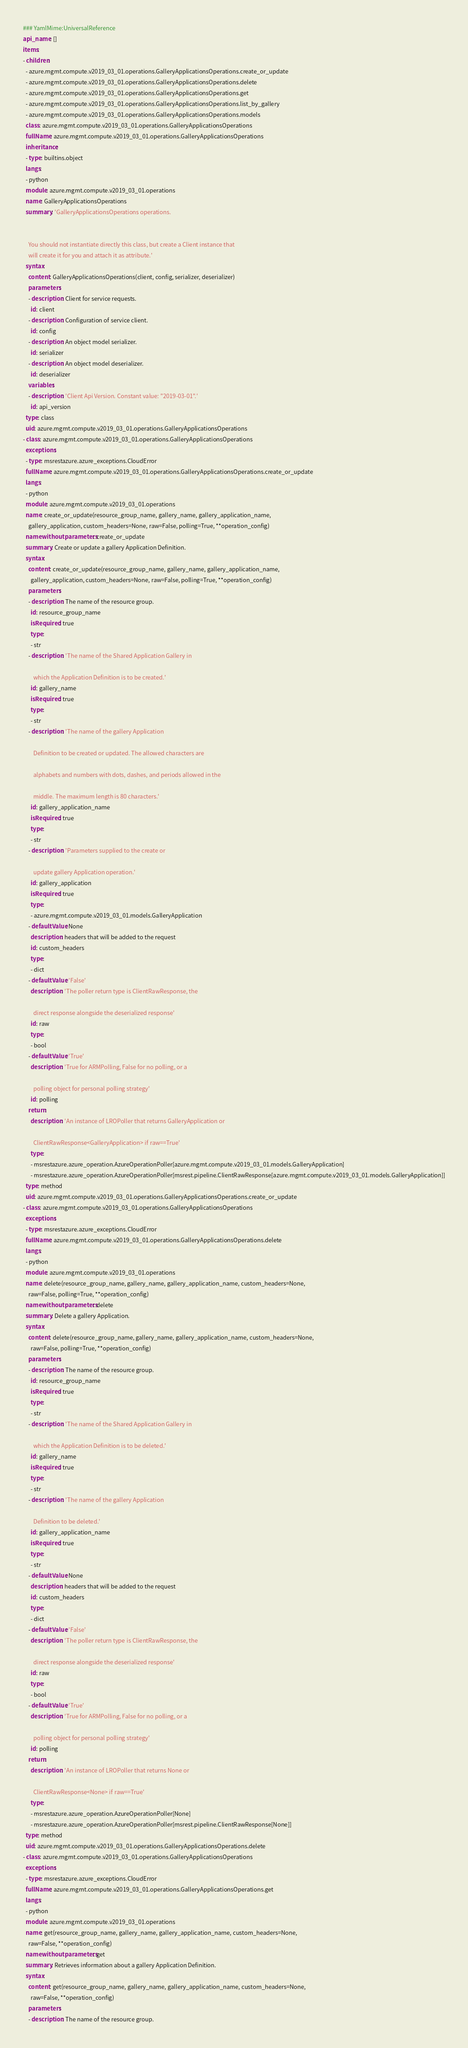<code> <loc_0><loc_0><loc_500><loc_500><_YAML_>### YamlMime:UniversalReference
api_name: []
items:
- children:
  - azure.mgmt.compute.v2019_03_01.operations.GalleryApplicationsOperations.create_or_update
  - azure.mgmt.compute.v2019_03_01.operations.GalleryApplicationsOperations.delete
  - azure.mgmt.compute.v2019_03_01.operations.GalleryApplicationsOperations.get
  - azure.mgmt.compute.v2019_03_01.operations.GalleryApplicationsOperations.list_by_gallery
  - azure.mgmt.compute.v2019_03_01.operations.GalleryApplicationsOperations.models
  class: azure.mgmt.compute.v2019_03_01.operations.GalleryApplicationsOperations
  fullName: azure.mgmt.compute.v2019_03_01.operations.GalleryApplicationsOperations
  inheritance:
  - type: builtins.object
  langs:
  - python
  module: azure.mgmt.compute.v2019_03_01.operations
  name: GalleryApplicationsOperations
  summary: 'GalleryApplicationsOperations operations.


    You should not instantiate directly this class, but create a Client instance that
    will create it for you and attach it as attribute.'
  syntax:
    content: GalleryApplicationsOperations(client, config, serializer, deserializer)
    parameters:
    - description: Client for service requests.
      id: client
    - description: Configuration of service client.
      id: config
    - description: An object model serializer.
      id: serializer
    - description: An object model deserializer.
      id: deserializer
    variables:
    - description: 'Client Api Version. Constant value: "2019-03-01".'
      id: api_version
  type: class
  uid: azure.mgmt.compute.v2019_03_01.operations.GalleryApplicationsOperations
- class: azure.mgmt.compute.v2019_03_01.operations.GalleryApplicationsOperations
  exceptions:
  - type: msrestazure.azure_exceptions.CloudError
  fullName: azure.mgmt.compute.v2019_03_01.operations.GalleryApplicationsOperations.create_or_update
  langs:
  - python
  module: azure.mgmt.compute.v2019_03_01.operations
  name: create_or_update(resource_group_name, gallery_name, gallery_application_name,
    gallery_application, custom_headers=None, raw=False, polling=True, **operation_config)
  namewithoutparameters: create_or_update
  summary: Create or update a gallery Application Definition.
  syntax:
    content: create_or_update(resource_group_name, gallery_name, gallery_application_name,
      gallery_application, custom_headers=None, raw=False, polling=True, **operation_config)
    parameters:
    - description: The name of the resource group.
      id: resource_group_name
      isRequired: true
      type:
      - str
    - description: 'The name of the Shared Application Gallery in

        which the Application Definition is to be created.'
      id: gallery_name
      isRequired: true
      type:
      - str
    - description: 'The name of the gallery Application

        Definition to be created or updated. The allowed characters are

        alphabets and numbers with dots, dashes, and periods allowed in the

        middle. The maximum length is 80 characters.'
      id: gallery_application_name
      isRequired: true
      type:
      - str
    - description: 'Parameters supplied to the create or

        update gallery Application operation.'
      id: gallery_application
      isRequired: true
      type:
      - azure.mgmt.compute.v2019_03_01.models.GalleryApplication
    - defaultValue: None
      description: headers that will be added to the request
      id: custom_headers
      type:
      - dict
    - defaultValue: 'False'
      description: 'The poller return type is ClientRawResponse, the

        direct response alongside the deserialized response'
      id: raw
      type:
      - bool
    - defaultValue: 'True'
      description: 'True for ARMPolling, False for no polling, or a

        polling object for personal polling strategy'
      id: polling
    return:
      description: 'An instance of LROPoller that returns GalleryApplication or

        ClientRawResponse<GalleryApplication> if raw==True'
      type:
      - msrestazure.azure_operation.AzureOperationPoller[azure.mgmt.compute.v2019_03_01.models.GalleryApplication]
      - msrestazure.azure_operation.AzureOperationPoller[msrest.pipeline.ClientRawResponse[azure.mgmt.compute.v2019_03_01.models.GalleryApplication]]
  type: method
  uid: azure.mgmt.compute.v2019_03_01.operations.GalleryApplicationsOperations.create_or_update
- class: azure.mgmt.compute.v2019_03_01.operations.GalleryApplicationsOperations
  exceptions:
  - type: msrestazure.azure_exceptions.CloudError
  fullName: azure.mgmt.compute.v2019_03_01.operations.GalleryApplicationsOperations.delete
  langs:
  - python
  module: azure.mgmt.compute.v2019_03_01.operations
  name: delete(resource_group_name, gallery_name, gallery_application_name, custom_headers=None,
    raw=False, polling=True, **operation_config)
  namewithoutparameters: delete
  summary: Delete a gallery Application.
  syntax:
    content: delete(resource_group_name, gallery_name, gallery_application_name, custom_headers=None,
      raw=False, polling=True, **operation_config)
    parameters:
    - description: The name of the resource group.
      id: resource_group_name
      isRequired: true
      type:
      - str
    - description: 'The name of the Shared Application Gallery in

        which the Application Definition is to be deleted.'
      id: gallery_name
      isRequired: true
      type:
      - str
    - description: 'The name of the gallery Application

        Definition to be deleted.'
      id: gallery_application_name
      isRequired: true
      type:
      - str
    - defaultValue: None
      description: headers that will be added to the request
      id: custom_headers
      type:
      - dict
    - defaultValue: 'False'
      description: 'The poller return type is ClientRawResponse, the

        direct response alongside the deserialized response'
      id: raw
      type:
      - bool
    - defaultValue: 'True'
      description: 'True for ARMPolling, False for no polling, or a

        polling object for personal polling strategy'
      id: polling
    return:
      description: 'An instance of LROPoller that returns None or

        ClientRawResponse<None> if raw==True'
      type:
      - msrestazure.azure_operation.AzureOperationPoller[None]
      - msrestazure.azure_operation.AzureOperationPoller[msrest.pipeline.ClientRawResponse[None]]
  type: method
  uid: azure.mgmt.compute.v2019_03_01.operations.GalleryApplicationsOperations.delete
- class: azure.mgmt.compute.v2019_03_01.operations.GalleryApplicationsOperations
  exceptions:
  - type: msrestazure.azure_exceptions.CloudError
  fullName: azure.mgmt.compute.v2019_03_01.operations.GalleryApplicationsOperations.get
  langs:
  - python
  module: azure.mgmt.compute.v2019_03_01.operations
  name: get(resource_group_name, gallery_name, gallery_application_name, custom_headers=None,
    raw=False, **operation_config)
  namewithoutparameters: get
  summary: Retrieves information about a gallery Application Definition.
  syntax:
    content: get(resource_group_name, gallery_name, gallery_application_name, custom_headers=None,
      raw=False, **operation_config)
    parameters:
    - description: The name of the resource group.</code> 